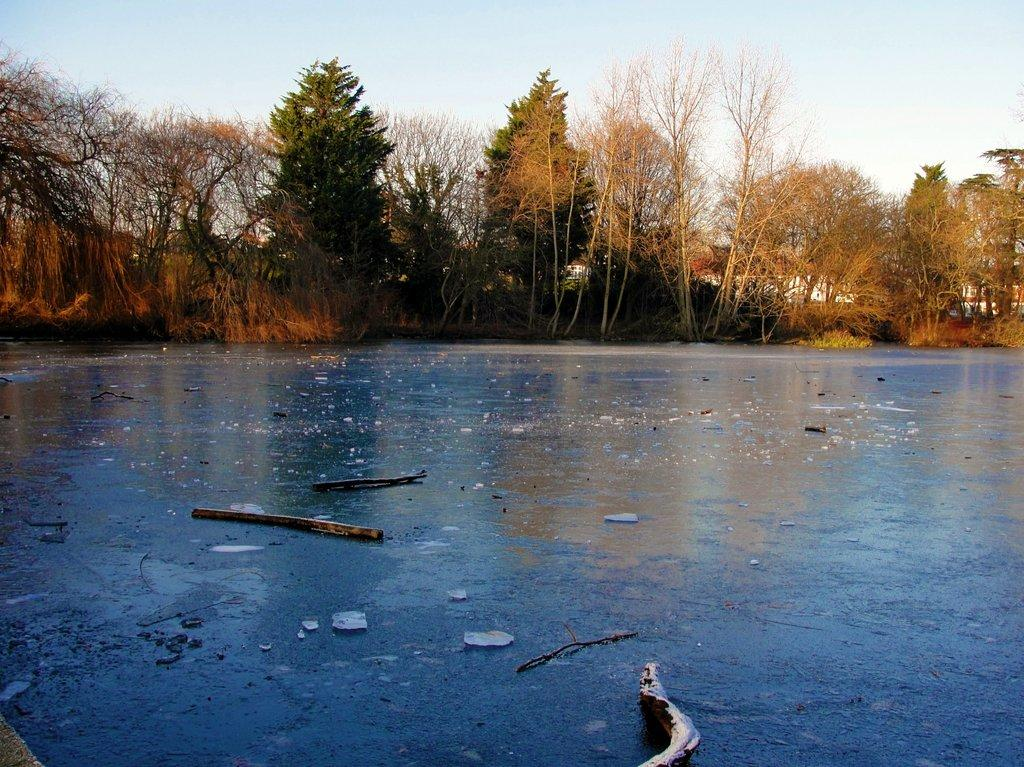What objects can be seen on the surface in the image? There are wooden sticks on the surface in the image. What type of natural environment is visible in the background of the image? There are trees in the background of the image. What type of man-made structures can be seen in the background of the image? There are houses in the background of the image. What is visible above the houses and trees in the image? The sky is visible in the background of the image. What type of oven is used to bake the wooden sticks in the image? There is no oven present in the image, and wooden sticks do not require baking. 